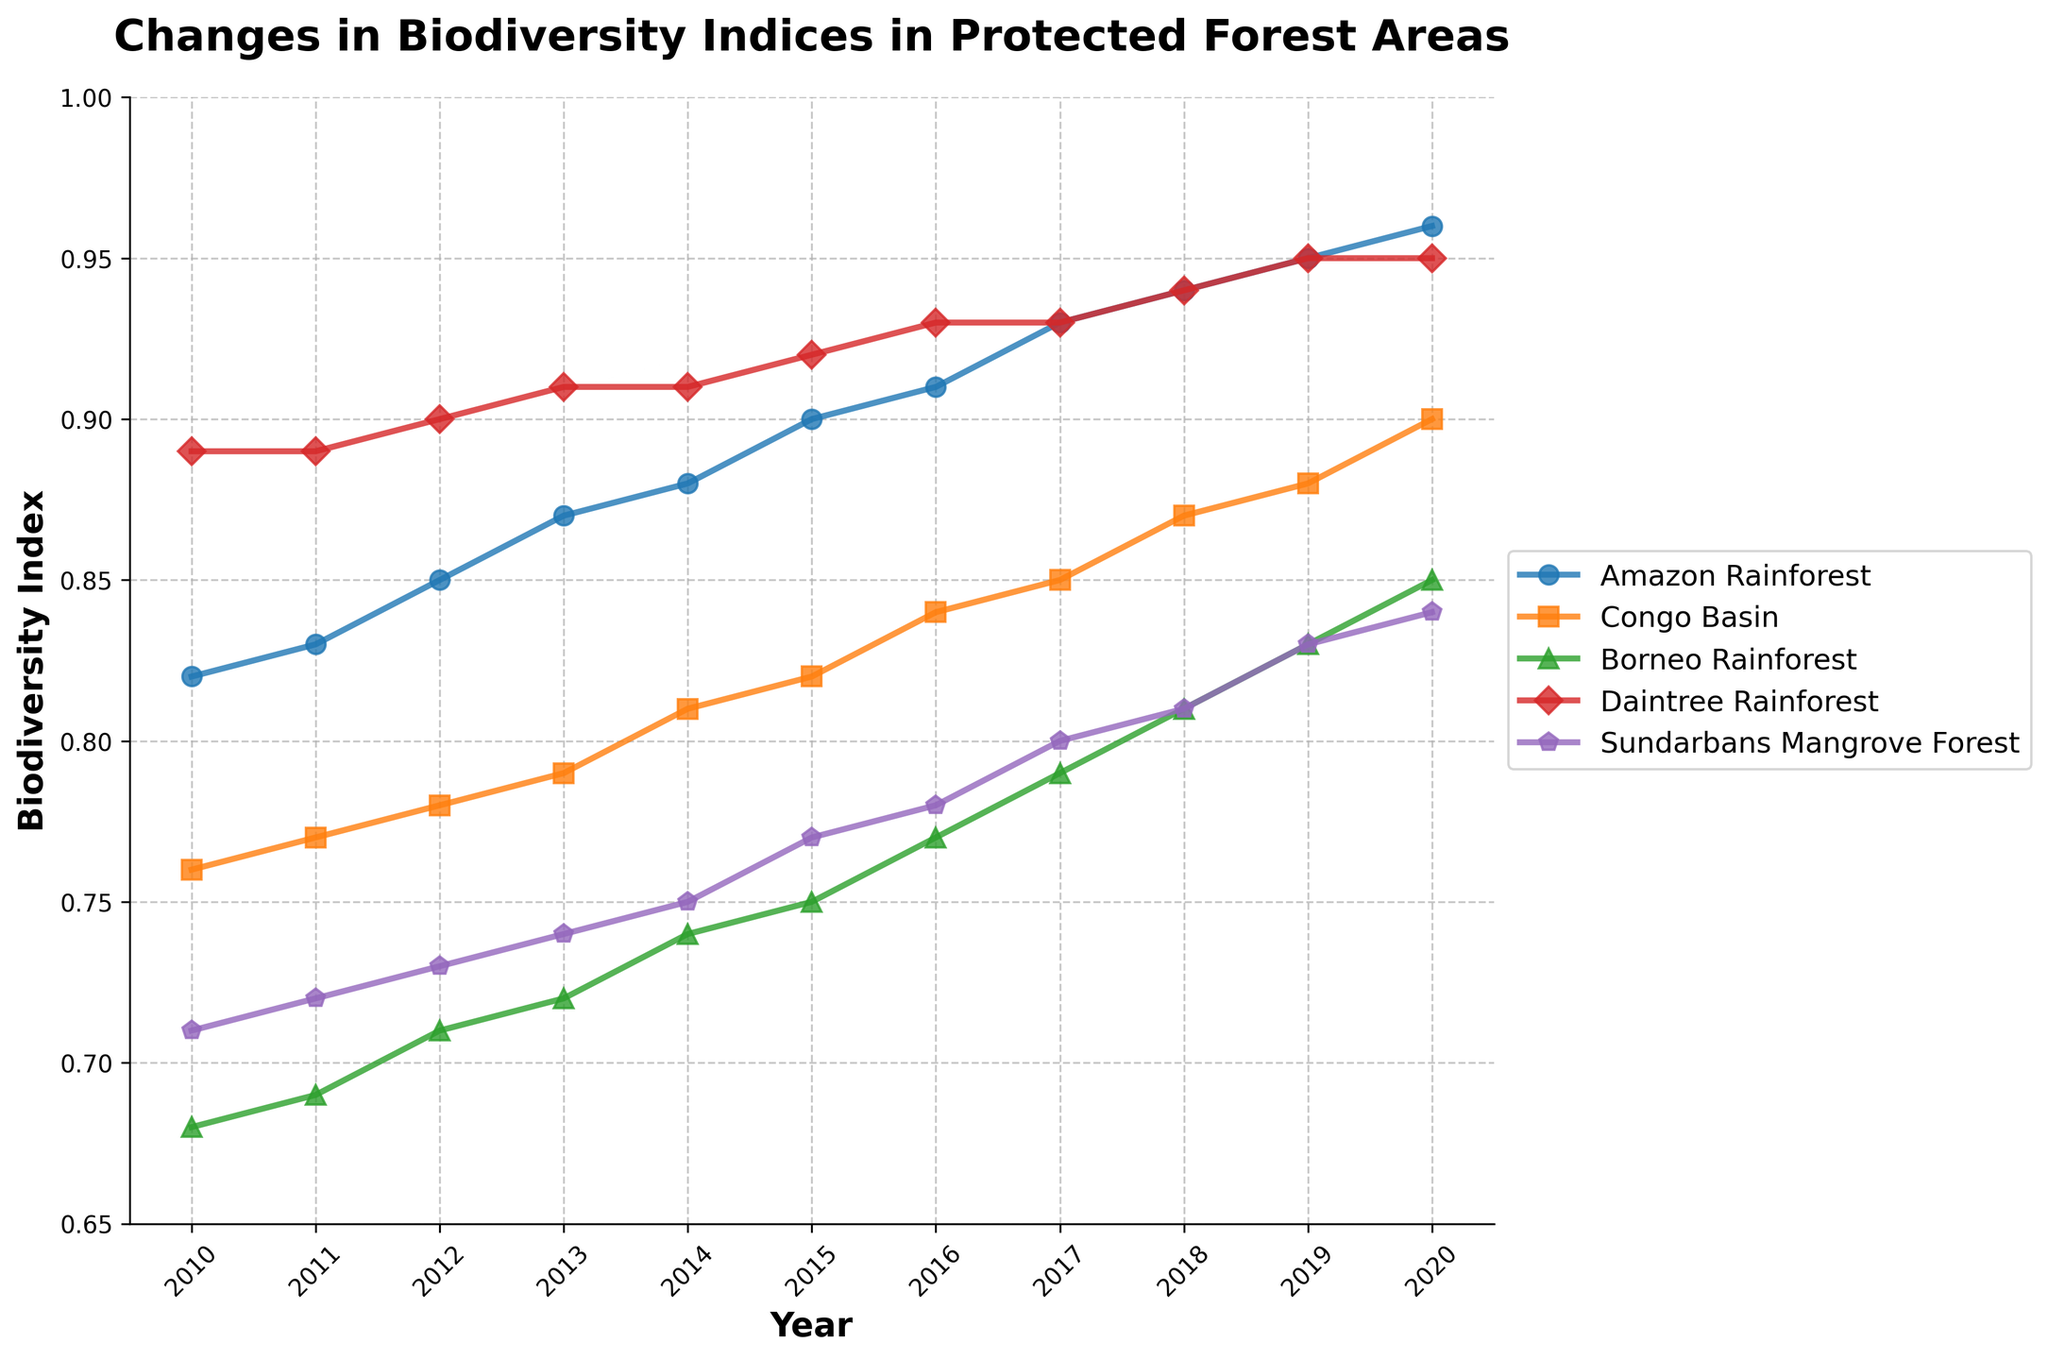what is the overall trend for the Amazon Rainforest biodiversity index from 2010 to 2020? The line representing the Amazon Rainforest shows a steady upward trend from 2010 to 2020, indicating an increase in the biodiversity index. The index begins at approximately 0.82 in 2010 and rises to approximately 0.96 in 2020.
Answer: Upward trend Which forest area had the highest biodiversity index in 2020? To determine this, look at the end values of each line plot for 2020. The Daintree Rainforest has the highest biodiversity index in 2020, with a value of approximately 0.95.
Answer: Daintree Rainforest How did the Congo Basin biodiversity index change between 2010 and 2015? In 2010, the Congo Basin's biodiversity index was approximately 0.76. By 2015, it increased to approximately 0.82. The change is calculated by subtracting the 2010 value from the 2015 value (0.82 - 0.76).
Answer: Increased by 0.06 Which forest showed the most significant positive change in biodiversity index from 2010 to 2020? To find this, compare the changes for each forest from 2010 to 2020. The Borneo Rainforest had the most significant increase, starting from approximately 0.68 in 2010 to approximately 0.85 in 2020. The difference is 0.85 - 0.68.
Answer: 0.17 increase During which year did the Sundarbans Mangrove Forest biodiversity index cross 0.80? Observe the data points for the Sundarbans Mangrove Forest. It crosses 0.80 between 2016 and 2017. By 2017, the index has reached approximately 0.80.
Answer: 2017 Rank the forests by their biodiversity index in 2015 from lowest to highest. In 2015, the biodiversity indices are Amazon Rainforest (~0.90), Congo Basin (~0.82), Borneo Rainforest (~0.75), Daintree Rainforest (~0.92), and Sundarbans Mangrove Forest (~0.77). Ordering these from lowest to highest gives: Borneo Rainforest, Sundarbans Mangrove Forest, Congo Basin, Amazon Rainforest, Daintree Rainforest.
Answer: Borneo, Sundarbans, Congo, Amazon, Daintree Compare the biodiversity index trends for Daintree Rainforest and Sundarbans Mangrove Forest from 2010 to 2020. The Daintree Rainforest has a consistent upward trend, starting at 0.89 in 2010 and reaching 0.95 in 2020. The Sundarbans also shows an upward trend but less consistently, starting at 0.71 in 2010 and reaching 0.84 in 2020.
Answer: Both upward, but Daintree more consistent What is the average biodiversity index for Borneo Rainforest across the entire period (2010-2020)? Sum the biodiversity indices for Borneo Rainforest over all years (0.68 + 0.69 + 0.71 + 0.72 + 0.74 + 0.75 + 0.77 + 0.79 + 0.81 + 0.83 + 0.85) and divide by the number of years (11).
Answer: 0.76 